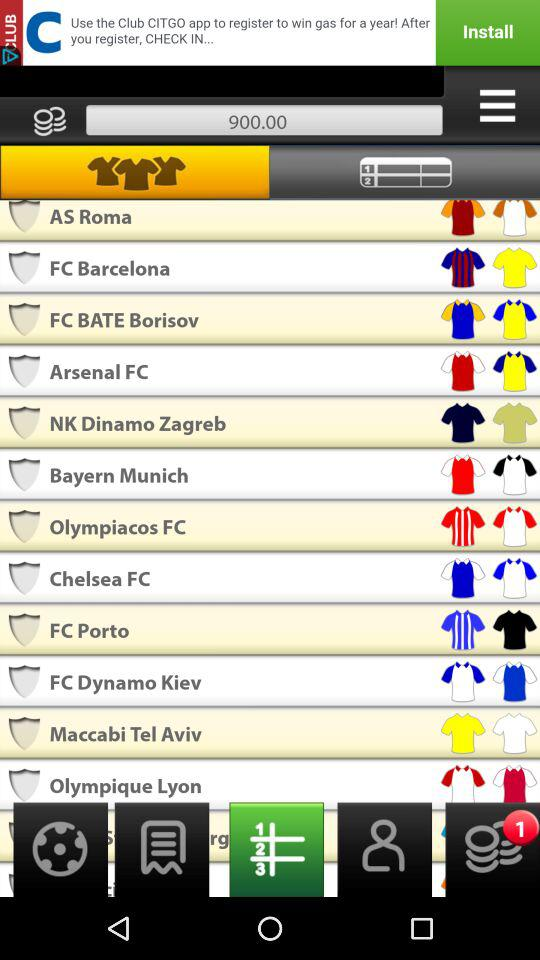What is the given number of coins? The number of coins is 900. 